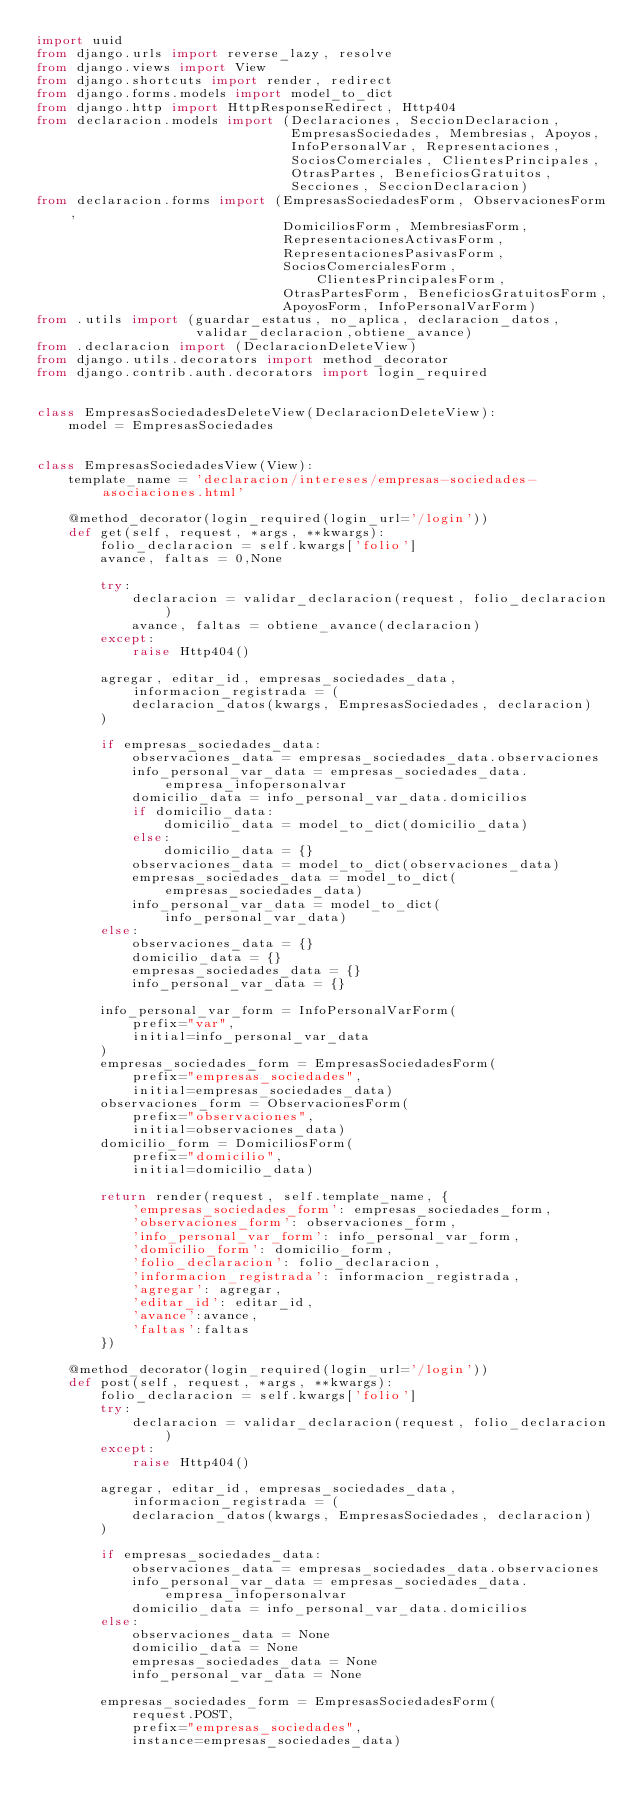<code> <loc_0><loc_0><loc_500><loc_500><_Python_>import uuid
from django.urls import reverse_lazy, resolve
from django.views import View
from django.shortcuts import render, redirect
from django.forms.models import model_to_dict
from django.http import HttpResponseRedirect, Http404
from declaracion.models import (Declaraciones, SeccionDeclaracion,
                                EmpresasSociedades, Membresias, Apoyos,
                                InfoPersonalVar, Representaciones,
                                SociosComerciales, ClientesPrincipales,
                                OtrasPartes, BeneficiosGratuitos,
                                Secciones, SeccionDeclaracion)
from declaracion.forms import (EmpresasSociedadesForm, ObservacionesForm,
                               DomiciliosForm, MembresiasForm,
                               RepresentacionesActivasForm,
                               RepresentacionesPasivasForm,
                               SociosComercialesForm, ClientesPrincipalesForm,
                               OtrasPartesForm, BeneficiosGratuitosForm,
                               ApoyosForm, InfoPersonalVarForm)
from .utils import (guardar_estatus, no_aplica, declaracion_datos,
                    validar_declaracion,obtiene_avance)
from .declaracion import (DeclaracionDeleteView)
from django.utils.decorators import method_decorator
from django.contrib.auth.decorators import login_required


class EmpresasSociedadesDeleteView(DeclaracionDeleteView):
    model = EmpresasSociedades


class EmpresasSociedadesView(View):
    template_name = 'declaracion/intereses/empresas-sociedades-asociaciones.html'

    @method_decorator(login_required(login_url='/login'))
    def get(self, request, *args, **kwargs):
        folio_declaracion = self.kwargs['folio']
        avance, faltas = 0,None

        try:
            declaracion = validar_declaracion(request, folio_declaracion)
            avance, faltas = obtiene_avance(declaracion)
        except:
            raise Http404()

        agregar, editar_id, empresas_sociedades_data, informacion_registrada = (
            declaracion_datos(kwargs, EmpresasSociedades, declaracion)
        )

        if empresas_sociedades_data:
            observaciones_data = empresas_sociedades_data.observaciones
            info_personal_var_data = empresas_sociedades_data.empresa_infopersonalvar
            domicilio_data = info_personal_var_data.domicilios
            if domicilio_data:
                domicilio_data = model_to_dict(domicilio_data)
            else:
                domicilio_data = {}
            observaciones_data = model_to_dict(observaciones_data)
            empresas_sociedades_data = model_to_dict(empresas_sociedades_data)
            info_personal_var_data = model_to_dict(info_personal_var_data)
        else:
            observaciones_data = {}
            domicilio_data = {}
            empresas_sociedades_data = {}
            info_personal_var_data = {}

        info_personal_var_form = InfoPersonalVarForm(
            prefix="var",
            initial=info_personal_var_data
        )
        empresas_sociedades_form = EmpresasSociedadesForm(
            prefix="empresas_sociedades",
            initial=empresas_sociedades_data)
        observaciones_form = ObservacionesForm(
            prefix="observaciones",
            initial=observaciones_data)
        domicilio_form = DomiciliosForm(
            prefix="domicilio",
            initial=domicilio_data)

        return render(request, self.template_name, {
            'empresas_sociedades_form': empresas_sociedades_form,
            'observaciones_form': observaciones_form,
            'info_personal_var_form': info_personal_var_form,
            'domicilio_form': domicilio_form,
            'folio_declaracion': folio_declaracion,
            'informacion_registrada': informacion_registrada,
            'agregar': agregar,
            'editar_id': editar_id,
            'avance':avance,
            'faltas':faltas
        })

    @method_decorator(login_required(login_url='/login'))
    def post(self, request, *args, **kwargs):
        folio_declaracion = self.kwargs['folio']
        try:
            declaracion = validar_declaracion(request, folio_declaracion)
        except:
            raise Http404()

        agregar, editar_id, empresas_sociedades_data, informacion_registrada = (
            declaracion_datos(kwargs, EmpresasSociedades, declaracion)
        )

        if empresas_sociedades_data:
            observaciones_data = empresas_sociedades_data.observaciones
            info_personal_var_data = empresas_sociedades_data.empresa_infopersonalvar
            domicilio_data = info_personal_var_data.domicilios
        else:
            observaciones_data = None
            domicilio_data = None
            empresas_sociedades_data = None
            info_personal_var_data = None

        empresas_sociedades_form = EmpresasSociedadesForm(
            request.POST,
            prefix="empresas_sociedades",
            instance=empresas_sociedades_data)</code> 